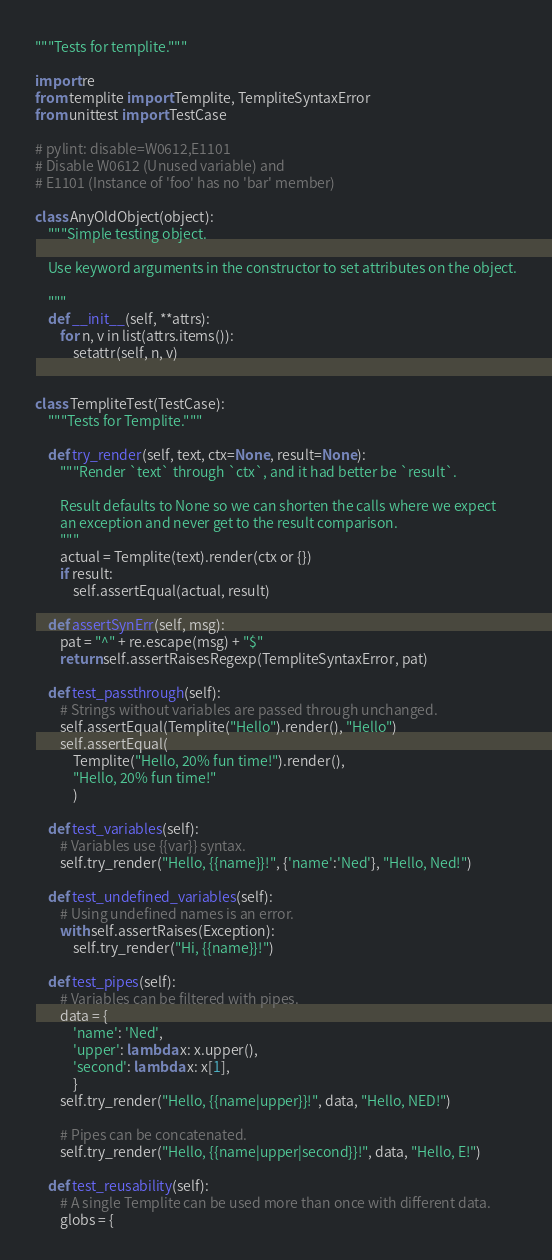Convert code to text. <code><loc_0><loc_0><loc_500><loc_500><_Python_>"""Tests for templite."""

import re
from templite import Templite, TempliteSyntaxError
from unittest import TestCase

# pylint: disable=W0612,E1101
# Disable W0612 (Unused variable) and
# E1101 (Instance of 'foo' has no 'bar' member)

class AnyOldObject(object):
    """Simple testing object.

    Use keyword arguments in the constructor to set attributes on the object.

    """
    def __init__(self, **attrs):
        for n, v in list(attrs.items()):
            setattr(self, n, v)


class TempliteTest(TestCase):
    """Tests for Templite."""

    def try_render(self, text, ctx=None, result=None):
        """Render `text` through `ctx`, and it had better be `result`.

        Result defaults to None so we can shorten the calls where we expect
        an exception and never get to the result comparison.
        """
        actual = Templite(text).render(ctx or {})
        if result:
            self.assertEqual(actual, result)

    def assertSynErr(self, msg):
        pat = "^" + re.escape(msg) + "$"
        return self.assertRaisesRegexp(TempliteSyntaxError, pat)

    def test_passthrough(self):
        # Strings without variables are passed through unchanged.
        self.assertEqual(Templite("Hello").render(), "Hello")
        self.assertEqual(
            Templite("Hello, 20% fun time!").render(),
            "Hello, 20% fun time!"
            )

    def test_variables(self):
        # Variables use {{var}} syntax.
        self.try_render("Hello, {{name}}!", {'name':'Ned'}, "Hello, Ned!")

    def test_undefined_variables(self):
        # Using undefined names is an error.
        with self.assertRaises(Exception):
            self.try_render("Hi, {{name}}!")

    def test_pipes(self):
        # Variables can be filtered with pipes.
        data = {
            'name': 'Ned',
            'upper': lambda x: x.upper(),
            'second': lambda x: x[1],
            }
        self.try_render("Hello, {{name|upper}}!", data, "Hello, NED!")

        # Pipes can be concatenated.
        self.try_render("Hello, {{name|upper|second}}!", data, "Hello, E!")

    def test_reusability(self):
        # A single Templite can be used more than once with different data.
        globs = {</code> 